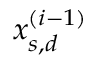Convert formula to latex. <formula><loc_0><loc_0><loc_500><loc_500>x _ { s , d } ^ { ( i - 1 ) }</formula> 